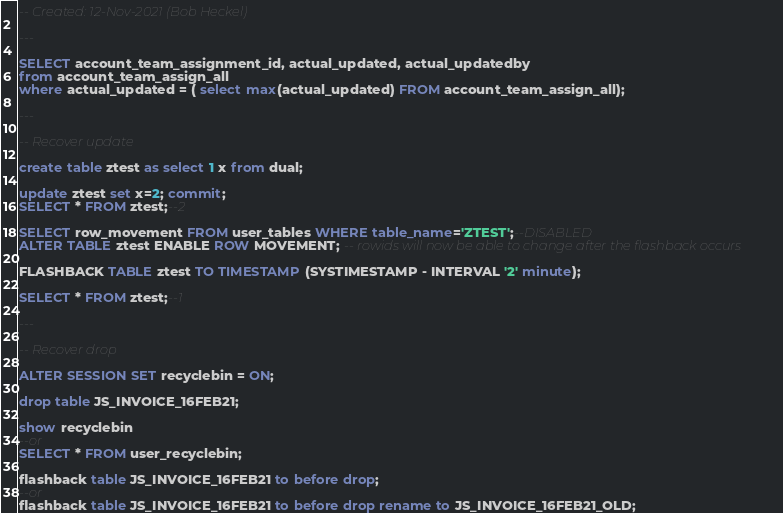Convert code to text. <code><loc_0><loc_0><loc_500><loc_500><_SQL_>-- Created: 12-Nov-2021 (Bob Heckel)

---

SELECT account_team_assignment_id, actual_updated, actual_updatedby
from account_team_assign_all
where actual_updated = ( select max(actual_updated) FROM account_team_assign_all);

---

-- Recover update

create table ztest as select 1 x from dual;

update ztest set x=2; commit;
SELECT * FROM ztest;--2

SELECT row_movement FROM user_tables WHERE table_name='ZTEST';--DISABLED
ALTER TABLE ztest ENABLE ROW MOVEMENT; -- rowids will now be able to change after the flashback occurs

FLASHBACK TABLE ztest TO TIMESTAMP (SYSTIMESTAMP - INTERVAL '2' minute);

SELECT * FROM ztest;--1

---

-- Recover drop

ALTER SESSION SET recyclebin = ON;

drop table JS_INVOICE_16FEB21;

show recyclebin
--or
SELECT * FROM user_recyclebin;

flashback table JS_INVOICE_16FEB21 to before drop;
--or
flashback table JS_INVOICE_16FEB21 to before drop rename to JS_INVOICE_16FEB21_OLD;
</code> 